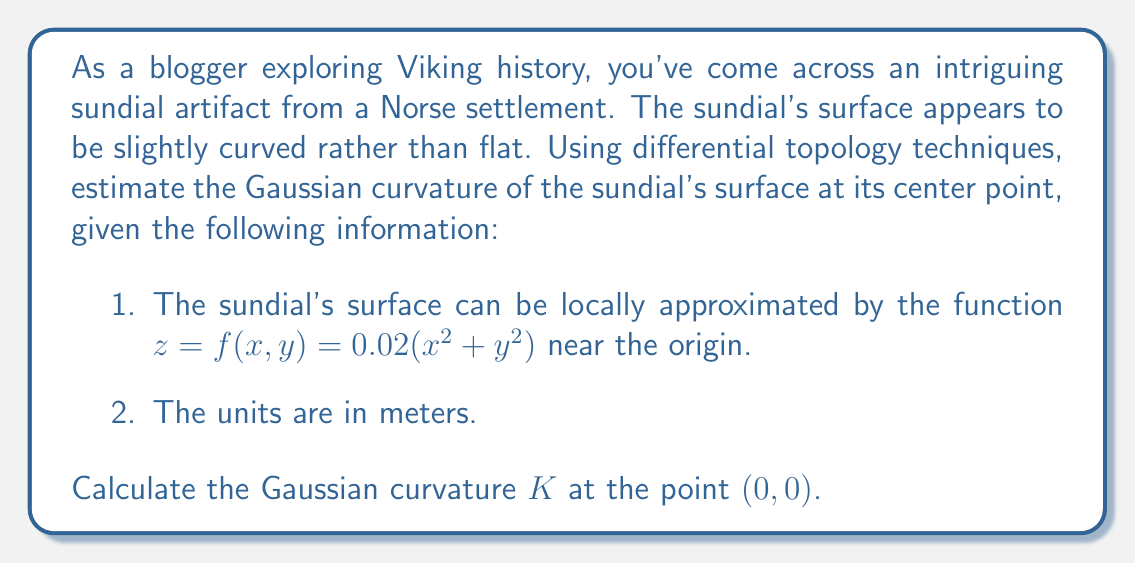Teach me how to tackle this problem. To estimate the Gaussian curvature of the Viking sundial's surface using differential topology, we'll follow these steps:

1) The Gaussian curvature $K$ at a point on a surface defined by $z = f(x,y)$ is given by the formula:

   $$K = \frac{f_{xx}f_{yy} - f_{xy}^2}{(1 + f_x^2 + f_y^2)^2}$$

   where $f_{xx}, f_{yy},$ and $f_{xy}$ are the second partial derivatives of $f$ with respect to $x$ and $y$.

2) Given function: $f(x,y) = 0.02(x^2 + y^2)$

3) Calculate the partial derivatives:
   
   $f_x = 0.04x$
   $f_y = 0.04y$
   $f_{xx} = 0.04$
   $f_{yy} = 0.04$
   $f_{xy} = 0$

4) At the point $(0,0)$:
   
   $f_x(0,0) = 0$
   $f_y(0,0) = 0$
   $f_{xx}(0,0) = 0.04$
   $f_{yy}(0,0) = 0.04$
   $f_{xy}(0,0) = 0$

5) Substitute these values into the Gaussian curvature formula:

   $$K = \frac{(0.04)(0.04) - 0^2}{(1 + 0^2 + 0^2)^2} = \frac{0.0016}{1} = 0.0016$$

6) Therefore, the Gaussian curvature at the center point $(0,0)$ of the Viking sundial is 0.0016 m^(-2).

This positive Gaussian curvature indicates that the sundial's surface is dome-shaped (convex) at its center, which could have been intentionally designed by Viking craftsmen to improve the sundial's accuracy or durability.
Answer: The Gaussian curvature $K$ at the center point $(0,0)$ of the Viking sundial is 0.0016 m^(-2). 